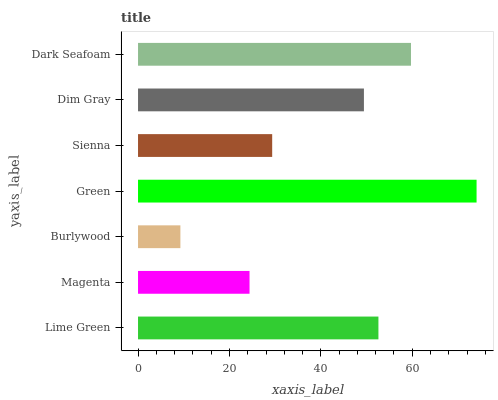Is Burlywood the minimum?
Answer yes or no. Yes. Is Green the maximum?
Answer yes or no. Yes. Is Magenta the minimum?
Answer yes or no. No. Is Magenta the maximum?
Answer yes or no. No. Is Lime Green greater than Magenta?
Answer yes or no. Yes. Is Magenta less than Lime Green?
Answer yes or no. Yes. Is Magenta greater than Lime Green?
Answer yes or no. No. Is Lime Green less than Magenta?
Answer yes or no. No. Is Dim Gray the high median?
Answer yes or no. Yes. Is Dim Gray the low median?
Answer yes or no. Yes. Is Dark Seafoam the high median?
Answer yes or no. No. Is Sienna the low median?
Answer yes or no. No. 